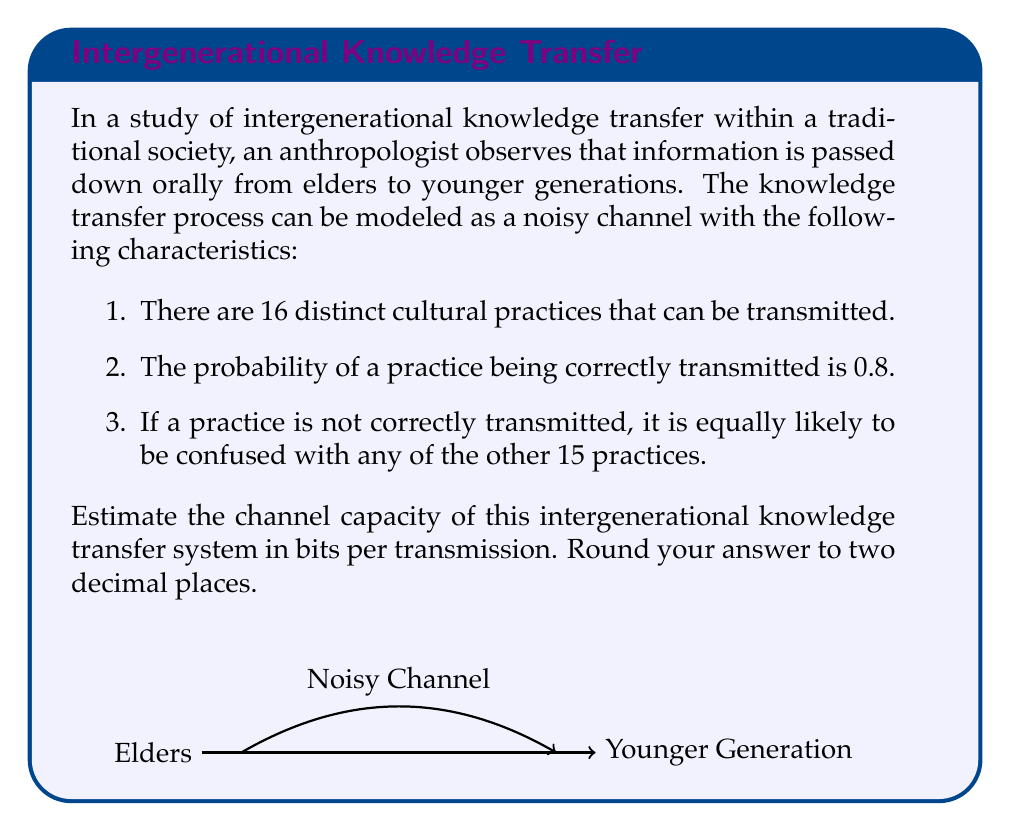Show me your answer to this math problem. To estimate the channel capacity, we'll use the mutual information formula for a discrete memoryless channel. The steps are as follows:

1) First, we need to calculate the entropy of the input $H(X)$:
   There are 16 equally likely practices, so:
   $$H(X) = -\sum_{i=1}^{16} \frac{1}{16} \log_2 \frac{1}{16} = \log_2 16 = 4 \text{ bits}$$

2) Next, we calculate the conditional entropy $H(Y|X)$:
   $$H(Y|X) = -[0.8 \log_2 0.8 + 15 \cdot (\frac{0.2}{15} \log_2 \frac{0.2}{15})]$$
   $$= -(0.8 \log_2 0.8 + 0.2 \log_2 \frac{0.2}{15})$$
   $$\approx 0.7219 \text{ bits}$$

3) The mutual information $I(X;Y)$ is:
   $$I(X;Y) = H(X) - H(Y|X)$$
   $$= 4 - 0.7219 = 3.2781 \text{ bits}$$

4) For a discrete memoryless channel, the channel capacity $C$ is equal to the maximum mutual information over all possible input distributions. In this case, the uniform distribution we used maximizes the mutual information.

Therefore, the channel capacity is approximately 3.28 bits per transmission.
Answer: 3.28 bits 